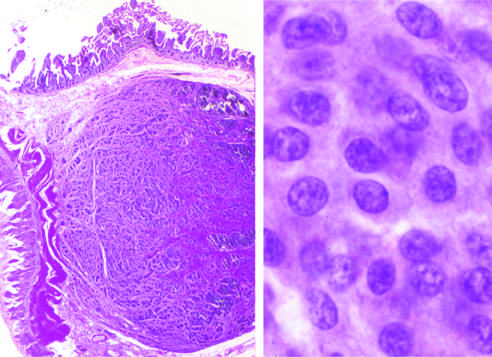what do carcinoid tumors form?
Answer the question using a single word or phrase. A submucosal nodule 